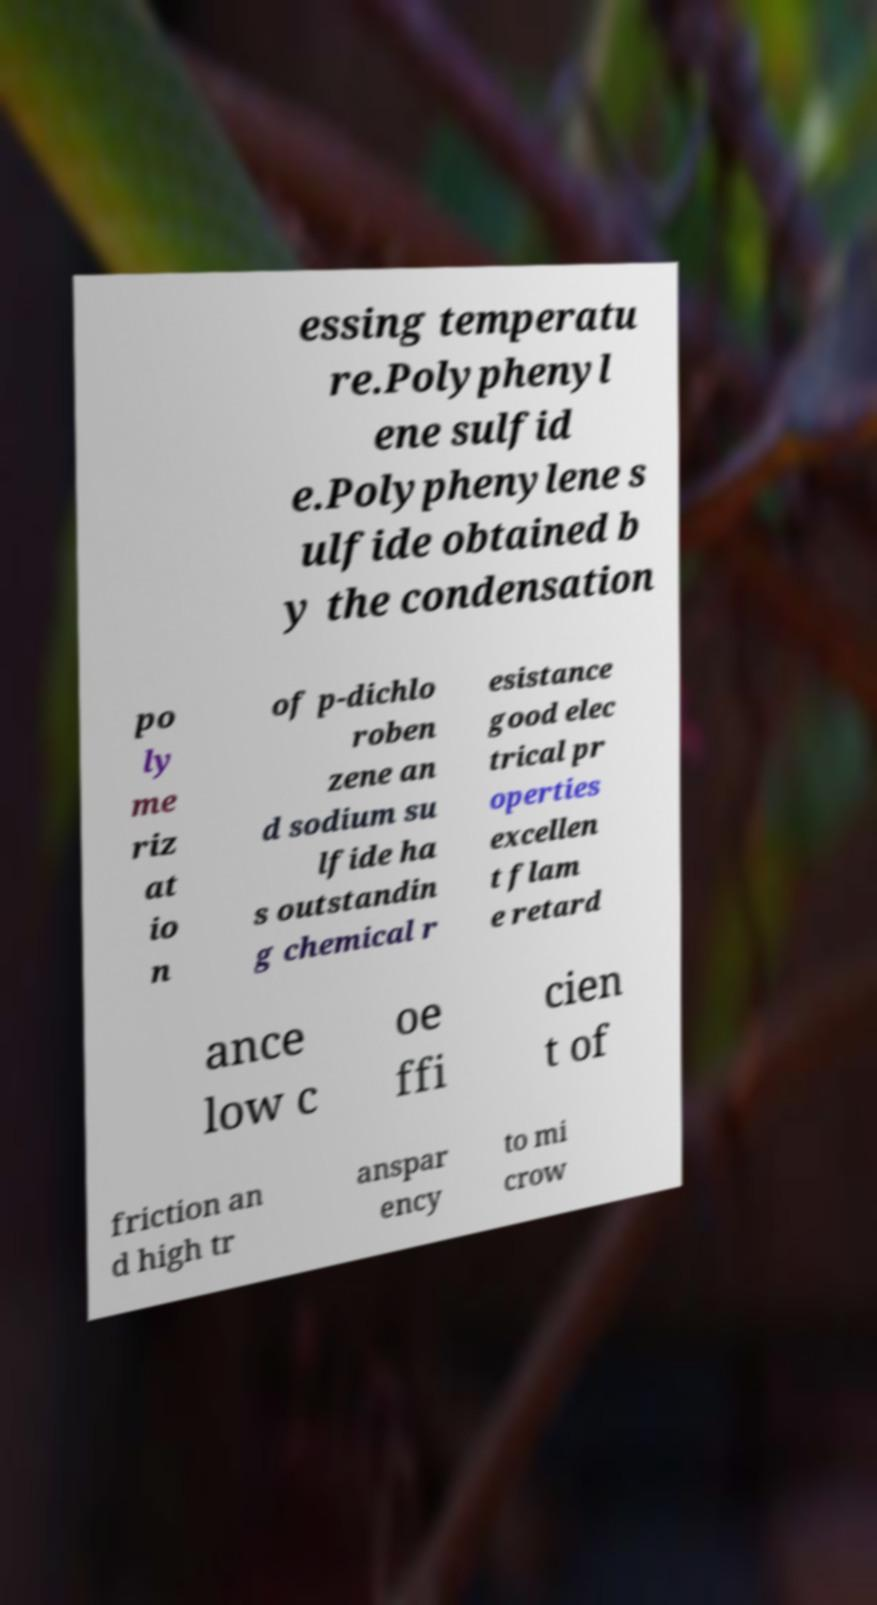Please read and relay the text visible in this image. What does it say? essing temperatu re.Polyphenyl ene sulfid e.Polyphenylene s ulfide obtained b y the condensation po ly me riz at io n of p-dichlo roben zene an d sodium su lfide ha s outstandin g chemical r esistance good elec trical pr operties excellen t flam e retard ance low c oe ffi cien t of friction an d high tr anspar ency to mi crow 